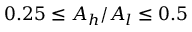<formula> <loc_0><loc_0><loc_500><loc_500>0 . 2 5 \leq A _ { h } / A _ { l } \leq 0 . 5</formula> 